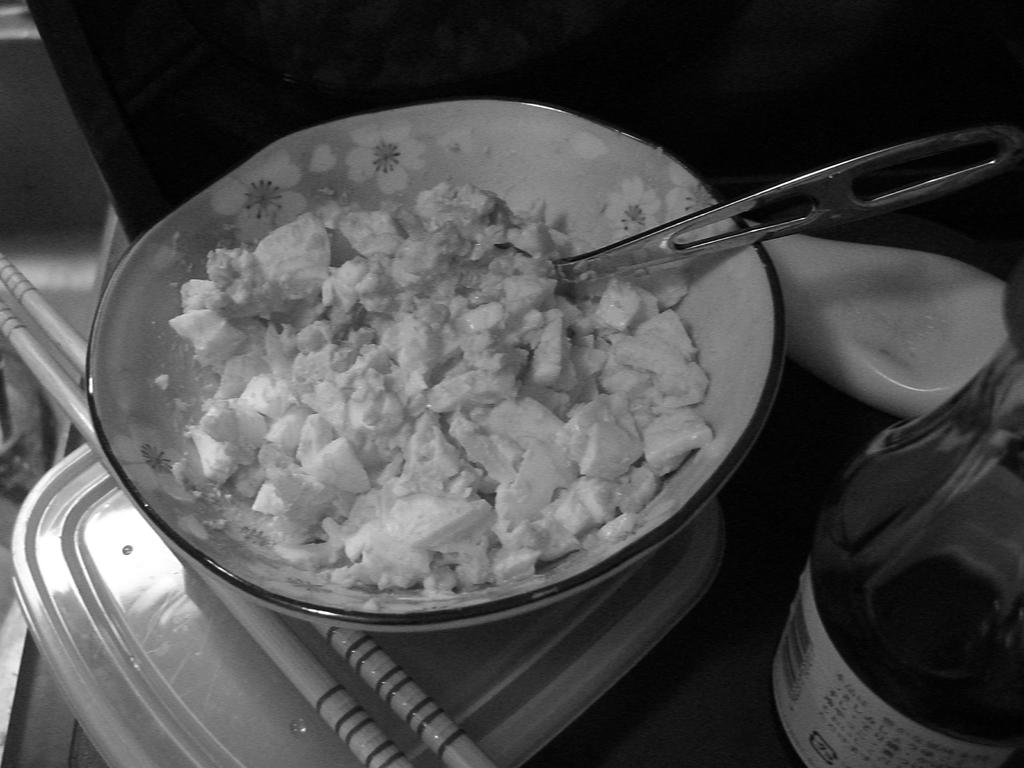What is the main piece of furniture in the image? There is a table in the image. What is placed on the table? There is a bowl on the table. What is inside the bowl? The bowl contains a food item. What is located beside the bowl? There is a bottle and a spoon beside the bowl. Are there any other objects on the table? Yes, there are additional objects on the table. What type of pear is being used as a decoration on the table in the image? There is no pear present in the image; it features a table with a bowl, a bottle, a spoon, and additional objects. 